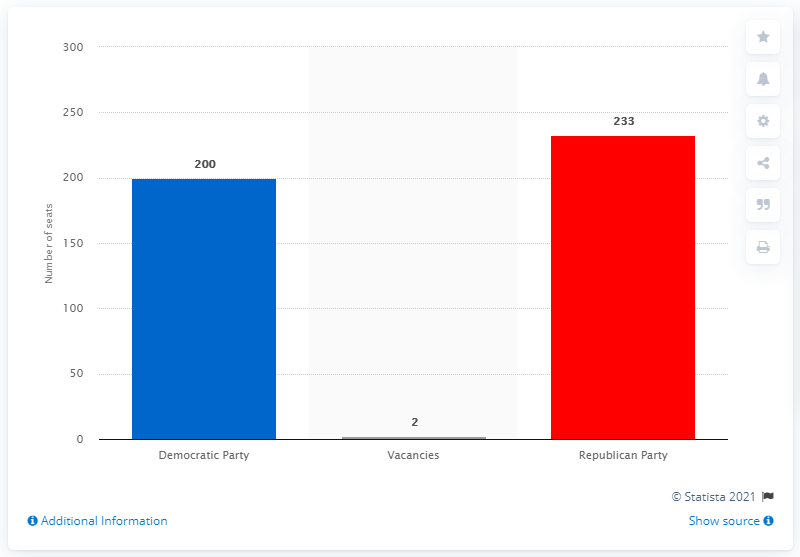Give some essential details in this illustration. In 2012, the Republican party held 233 seats in the House of Representatives. 